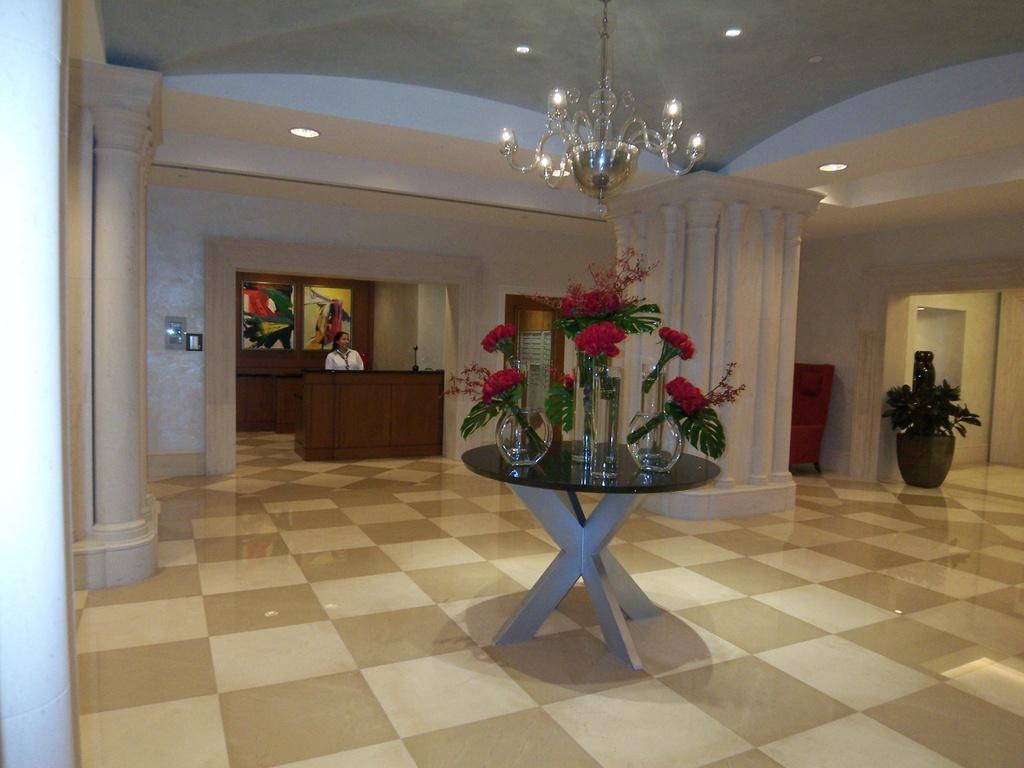Describe this image in one or two sentences. In this picture we can see a room which consisting of table, there are some glass bowls on the table and some bunch of flowers on bowls in the background we can see a woman standing at a desk and also we can see some lamp here on the right side of the picture we can see a plant. 